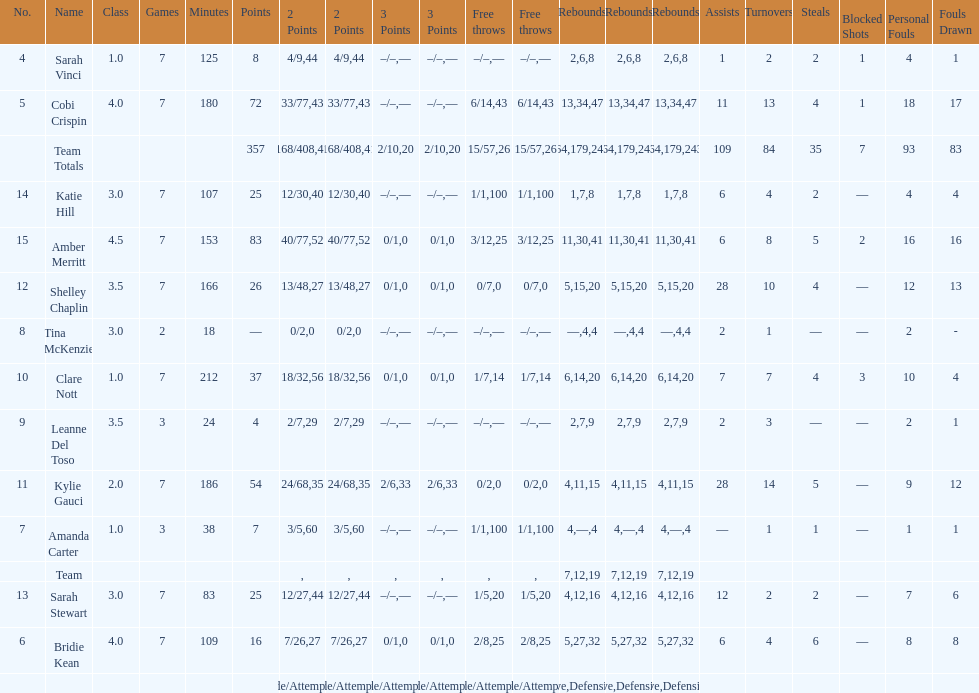After playing seven games, how many players individual points were above 30? 4. 